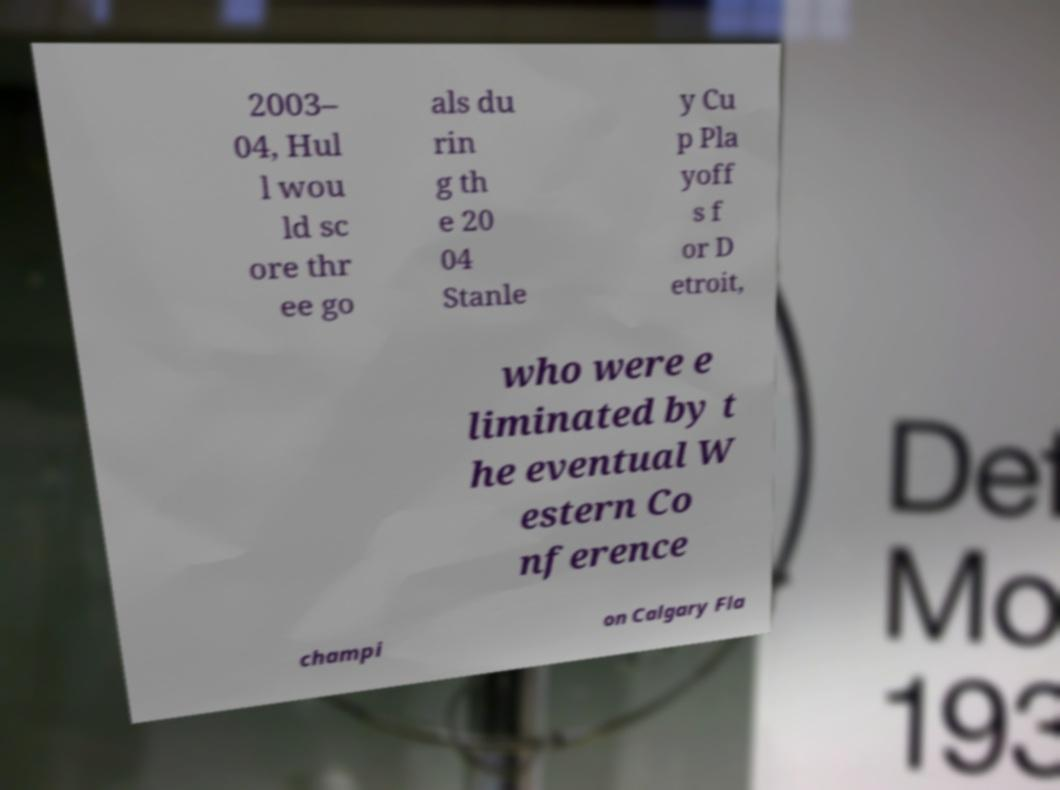Please read and relay the text visible in this image. What does it say? 2003– 04, Hul l wou ld sc ore thr ee go als du rin g th e 20 04 Stanle y Cu p Pla yoff s f or D etroit, who were e liminated by t he eventual W estern Co nference champi on Calgary Fla 